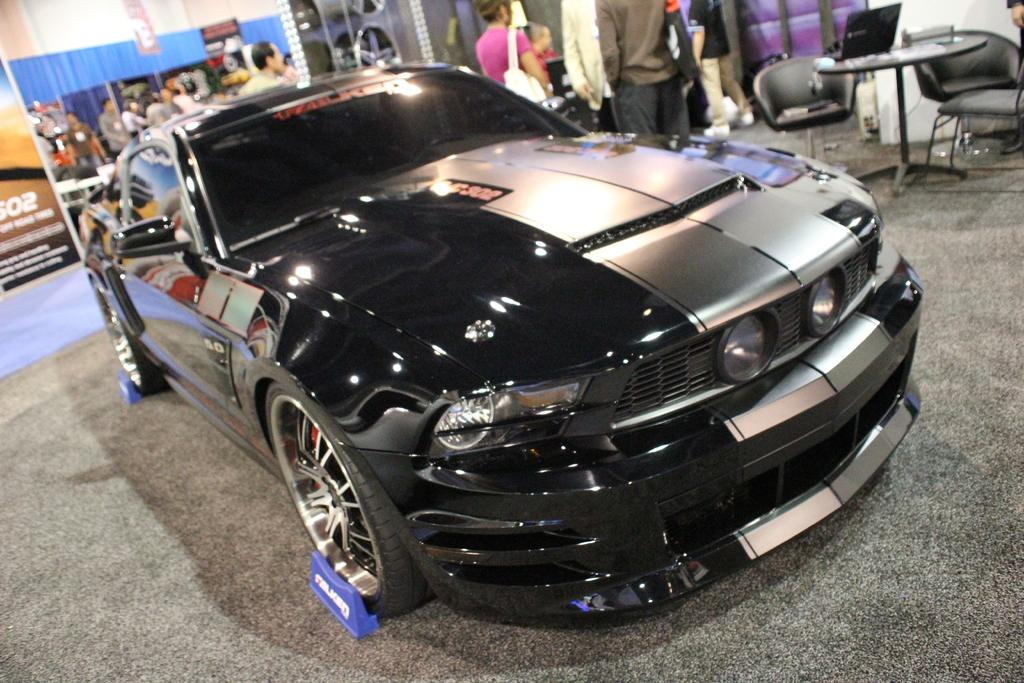What is the main subject of the image? The main subject of the image is a car. What can be seen behind the car? There are hoardings behind the car. Can you describe the people in the image? There is a group of people in the image. What type of furniture is present in the image? There are tables and chairs in the image. What electronic device can be seen in the image? There is a laptop in the image. What type of garden can be seen in the image? There is no garden present in the image. How does the ink from the laptop spill onto the car in the image? There is no ink spilling from the laptop in the image; it is not present. 